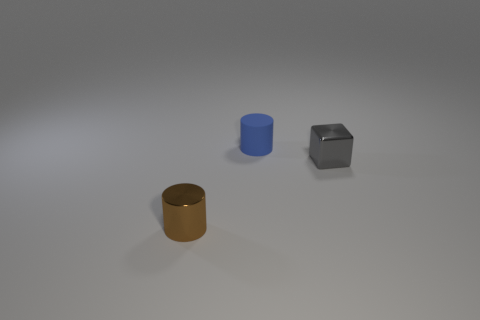What number of small blocks have the same material as the gray thing?
Your answer should be very brief. 0. There is a small thing that is behind the metallic cylinder and in front of the small blue matte object; what is its shape?
Provide a succinct answer. Cube. Is the cylinder that is behind the small metallic cube made of the same material as the gray thing?
Provide a short and direct response. No. Are there any other things that have the same material as the brown cylinder?
Ensure brevity in your answer.  Yes. What color is the metal block that is the same size as the rubber cylinder?
Give a very brief answer. Gray. Are there any small balls of the same color as the metallic cube?
Keep it short and to the point. No. What size is the brown object that is made of the same material as the gray thing?
Ensure brevity in your answer.  Small. How many other objects are the same size as the blue thing?
Provide a succinct answer. 2. There is a object right of the small blue cylinder; what material is it?
Provide a succinct answer. Metal. There is a small object that is on the left side of the cylinder that is behind the metallic thing that is on the right side of the blue matte cylinder; what is its shape?
Make the answer very short. Cylinder. 